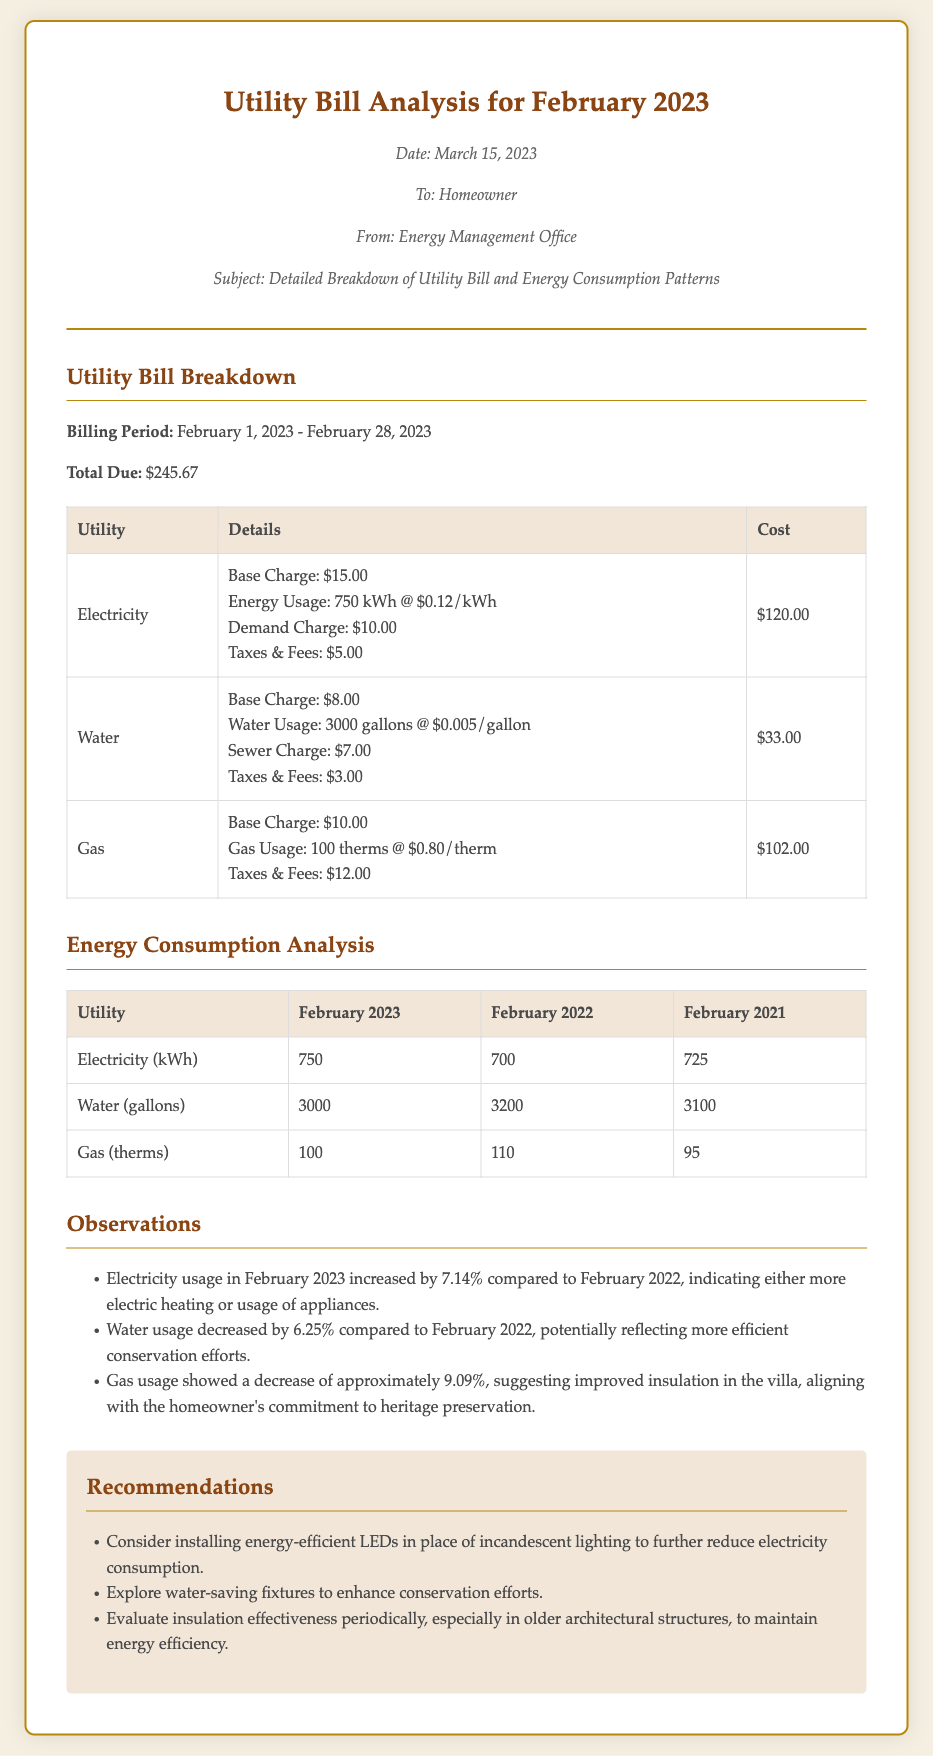what was the total due for February 2023? The total due is provided in the document as the overall amount for the utility bill for February 2023.
Answer: $245.67 how much was the electricity base charge? The base charge for electricity is specified in the breakdown of utility charges within the document.
Answer: $15.00 what was the water usage in gallons for February 2022? The document contains a comparison of water usage across multiple years, including February 2022.
Answer: 3200 how much did gas usage decrease in percentage from February 2022 to February 2023? The document states the gas usage for both years and provides the percentage of decrease for reasoned analysis.
Answer: 9.09% what is one recommendation provided in the memo? The recommendations section lists several suggestions aimed at improving energy efficiency, which can be directly referenced.
Answer: Consider installing energy-efficient LEDs what was the demand charge stated for electricity? The breakdown of charges includes specific fees associated with electricity usage, including the demand charge.
Answer: $10.00 what was the water base charge listed in the document? The document provides a specific detail regarding the basic fees associated with water services, which can be directly retrieved.
Answer: $8.00 who prepared the memo? The document specifies who it is addressed to and who has authored it, providing clear authorship information.
Answer: Energy Management Office how many therms of gas were used in February 2023? The energy consumption analysis table provides specific figures for gas usage for February 2023, which can be directly retrieved from the mentioned table.
Answer: 100 